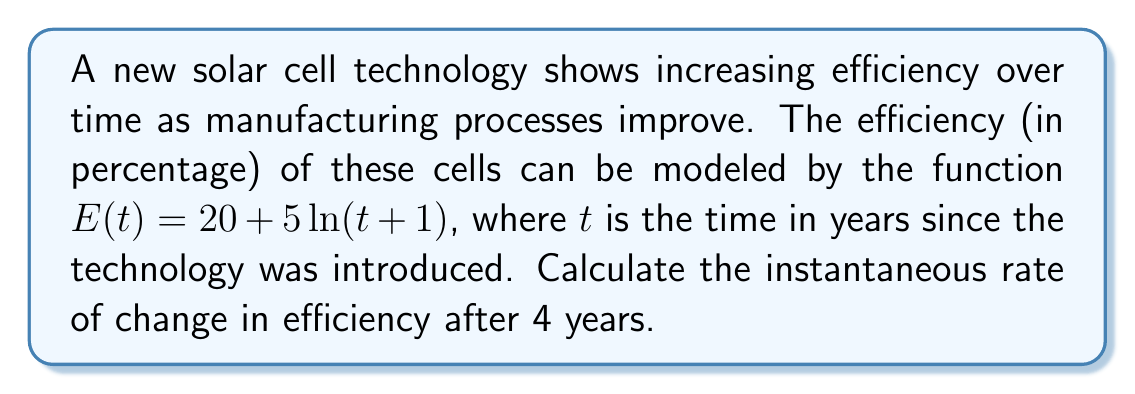Teach me how to tackle this problem. To find the instantaneous rate of change in efficiency after 4 years, we need to calculate the derivative of the function $E(t)$ and evaluate it at $t=4$.

1. Given function: $E(t) = 20 + 5\ln(t+1)$

2. To find the derivative, we use the chain rule:
   $$\frac{dE}{dt} = 5 \cdot \frac{d}{dt}[\ln(t+1)]$$
   $$\frac{dE}{dt} = 5 \cdot \frac{1}{t+1}$$

3. Now we evaluate the derivative at $t=4$:
   $$\left.\frac{dE}{dt}\right|_{t=4} = 5 \cdot \frac{1}{4+1} = 5 \cdot \frac{1}{5} = 1$$

This result represents the instantaneous rate of change in efficiency (in percentage points per year) after 4 years.
Answer: The instantaneous rate of change in solar cell efficiency after 4 years is 1 percentage point per year. 